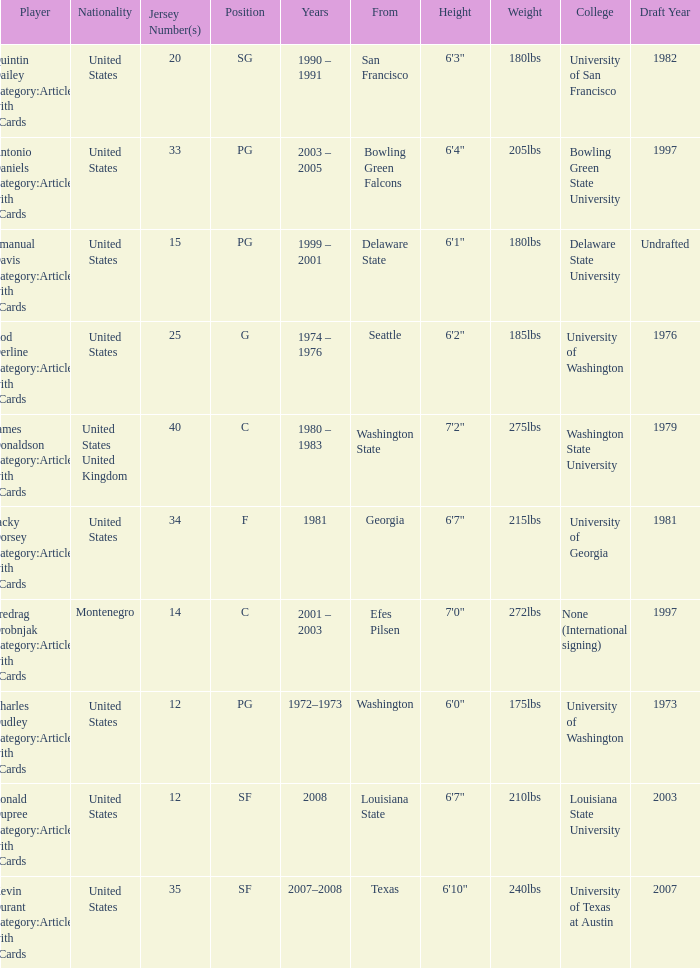What years did the united states player with a jersey number 25 who attended delaware state play? 1999 – 2001. 